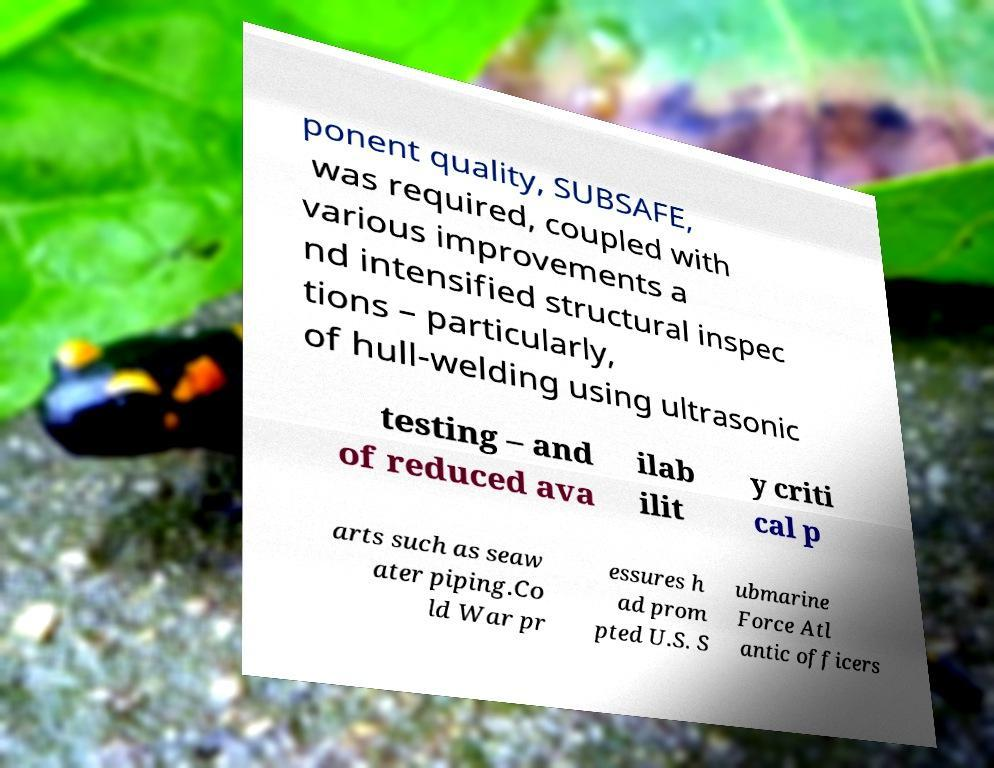There's text embedded in this image that I need extracted. Can you transcribe it verbatim? ponent quality, SUBSAFE, was required, coupled with various improvements a nd intensified structural inspec tions – particularly, of hull-welding using ultrasonic testing – and of reduced ava ilab ilit y criti cal p arts such as seaw ater piping.Co ld War pr essures h ad prom pted U.S. S ubmarine Force Atl antic officers 